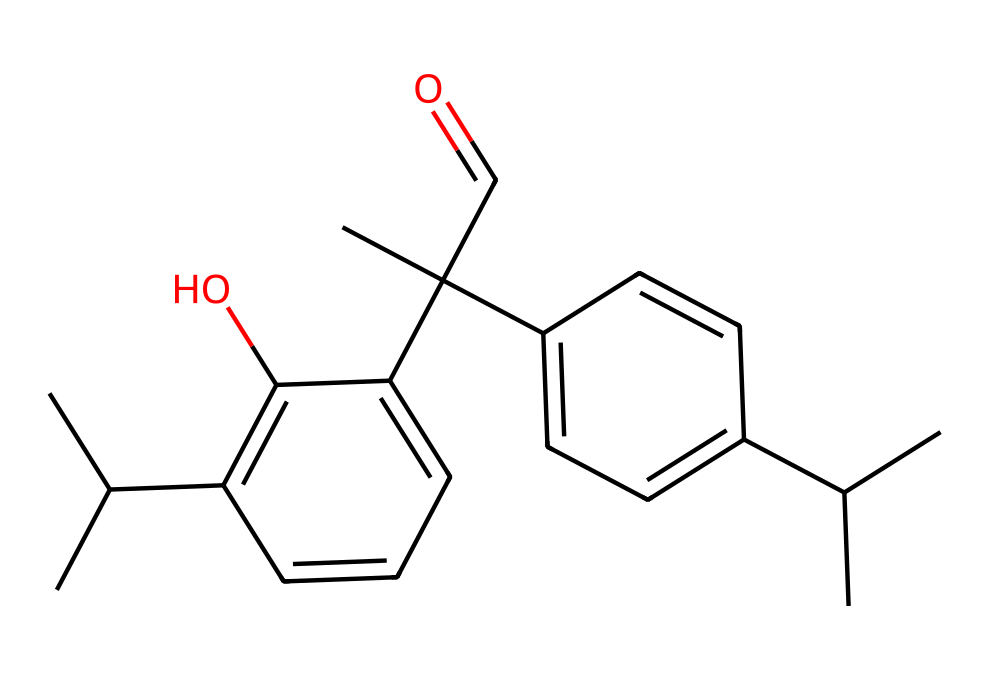What is the main functional group present in this chemical? The chemical contains a hydroxyl group (-OH), which is characteristic of alcohols. This can be identified by observing the presence of a carbon atom directly bonded to the -OH group.
Answer: hydroxyl group How many carbon atoms are in this chemical? By analyzing the SMILES representation, I can count a total of 21 carbon atoms, as each "C" in the structure indicates a carbon atom.
Answer: 21 What is the degree of unsaturation in this chemical? The degree of unsaturation can be determined by the formula (2C + 2 + N - H - X) / 2. Applying this to the molecular formula derived from the SMILES yields a degree of unsaturation of 5, indicating rings or double bonds in the structure.
Answer: 5 Does this compound contain any aromatic rings? The chemical structure includes several cyclic components, as indicated by the presence of alternating double bonds in segments of the structure, which is characteristic of aromatic compounds.
Answer: yes What type of sunscreen agent is represented by this compound? This chemical has characteristics typical of a physical (inorganic) sunscreen agent due to its complex aromatic structure, which often correlates with UV absorption properties in topical formulations.
Answer: physical sunscreen agent 